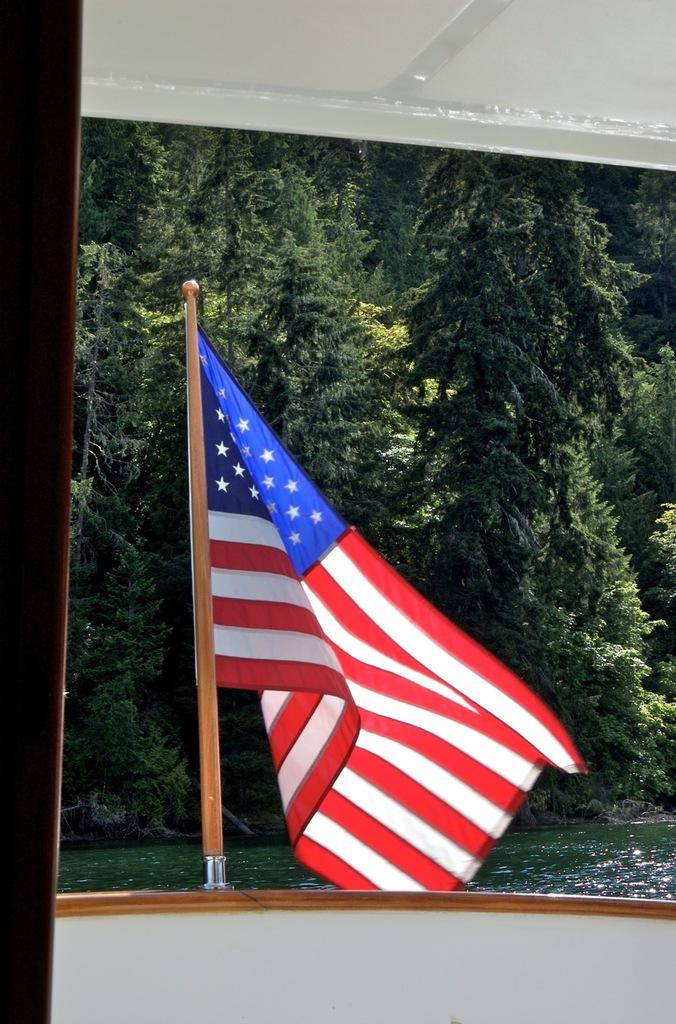What is the main subject of the image? The main subject of the image is a boat. Where is the boat located? The boat is on the water. What is attached to the boat? There is a flag on the boat. What can be seen in the background of the image? There are trees in the background of the image. What type of jellyfish can be seen swimming near the boat in the image? There are no jellyfish present in the image; the boat is on the water, but no marine life is mentioned or visible. 